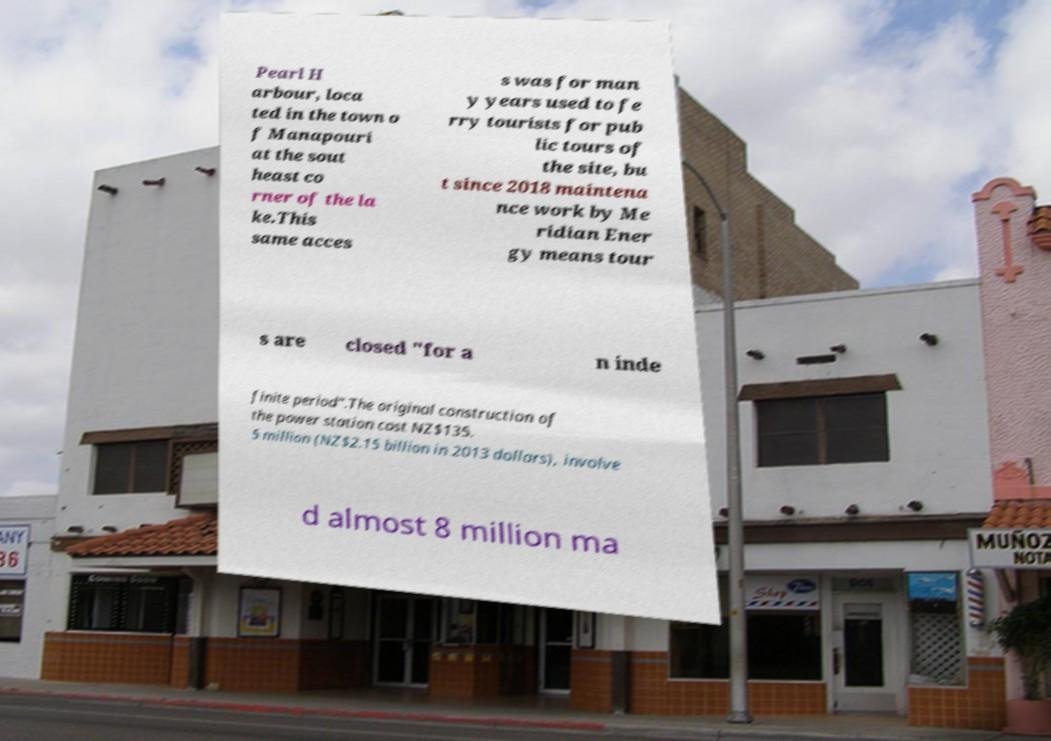Could you extract and type out the text from this image? Pearl H arbour, loca ted in the town o f Manapouri at the sout heast co rner of the la ke.This same acces s was for man y years used to fe rry tourists for pub lic tours of the site, bu t since 2018 maintena nce work by Me ridian Ener gy means tour s are closed "for a n inde finite period".The original construction of the power station cost NZ$135. 5 million (NZ$2.15 billion in 2013 dollars), involve d almost 8 million ma 